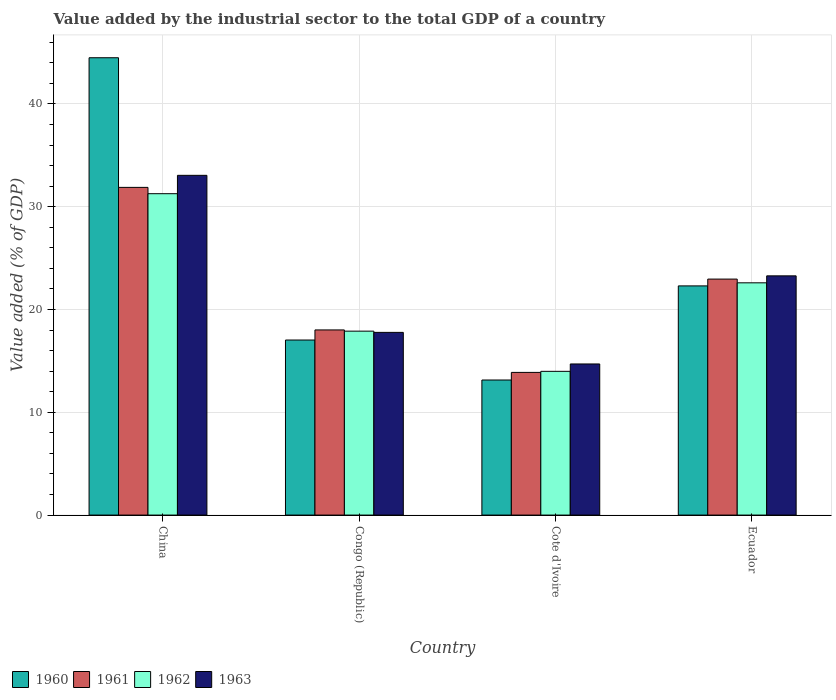How many groups of bars are there?
Offer a very short reply. 4. How many bars are there on the 4th tick from the left?
Your answer should be very brief. 4. What is the label of the 4th group of bars from the left?
Your answer should be compact. Ecuador. In how many cases, is the number of bars for a given country not equal to the number of legend labels?
Keep it short and to the point. 0. What is the value added by the industrial sector to the total GDP in 1963 in Congo (Republic)?
Your answer should be compact. 17.77. Across all countries, what is the maximum value added by the industrial sector to the total GDP in 1962?
Make the answer very short. 31.26. Across all countries, what is the minimum value added by the industrial sector to the total GDP in 1961?
Your answer should be compact. 13.88. In which country was the value added by the industrial sector to the total GDP in 1963 maximum?
Your answer should be compact. China. In which country was the value added by the industrial sector to the total GDP in 1961 minimum?
Offer a very short reply. Cote d'Ivoire. What is the total value added by the industrial sector to the total GDP in 1960 in the graph?
Ensure brevity in your answer.  96.95. What is the difference between the value added by the industrial sector to the total GDP in 1960 in China and that in Ecuador?
Ensure brevity in your answer.  22.19. What is the difference between the value added by the industrial sector to the total GDP in 1960 in Ecuador and the value added by the industrial sector to the total GDP in 1962 in Congo (Republic)?
Ensure brevity in your answer.  4.4. What is the average value added by the industrial sector to the total GDP in 1962 per country?
Your answer should be very brief. 21.43. What is the difference between the value added by the industrial sector to the total GDP of/in 1963 and value added by the industrial sector to the total GDP of/in 1961 in Cote d'Ivoire?
Your answer should be compact. 0.82. In how many countries, is the value added by the industrial sector to the total GDP in 1962 greater than 30 %?
Keep it short and to the point. 1. What is the ratio of the value added by the industrial sector to the total GDP in 1962 in China to that in Congo (Republic)?
Your answer should be compact. 1.75. Is the difference between the value added by the industrial sector to the total GDP in 1963 in Congo (Republic) and Cote d'Ivoire greater than the difference between the value added by the industrial sector to the total GDP in 1961 in Congo (Republic) and Cote d'Ivoire?
Give a very brief answer. No. What is the difference between the highest and the second highest value added by the industrial sector to the total GDP in 1963?
Your answer should be very brief. 15.28. What is the difference between the highest and the lowest value added by the industrial sector to the total GDP in 1963?
Keep it short and to the point. 18.35. Is it the case that in every country, the sum of the value added by the industrial sector to the total GDP in 1963 and value added by the industrial sector to the total GDP in 1962 is greater than the sum of value added by the industrial sector to the total GDP in 1960 and value added by the industrial sector to the total GDP in 1961?
Your response must be concise. No. What does the 1st bar from the left in Ecuador represents?
Give a very brief answer. 1960. What does the 3rd bar from the right in Congo (Republic) represents?
Offer a terse response. 1961. How many countries are there in the graph?
Provide a short and direct response. 4. Where does the legend appear in the graph?
Ensure brevity in your answer.  Bottom left. How many legend labels are there?
Provide a succinct answer. 4. How are the legend labels stacked?
Keep it short and to the point. Horizontal. What is the title of the graph?
Keep it short and to the point. Value added by the industrial sector to the total GDP of a country. Does "2011" appear as one of the legend labels in the graph?
Offer a terse response. No. What is the label or title of the X-axis?
Offer a very short reply. Country. What is the label or title of the Y-axis?
Keep it short and to the point. Value added (% of GDP). What is the Value added (% of GDP) in 1960 in China?
Your response must be concise. 44.49. What is the Value added (% of GDP) in 1961 in China?
Offer a very short reply. 31.88. What is the Value added (% of GDP) in 1962 in China?
Your answer should be compact. 31.26. What is the Value added (% of GDP) in 1963 in China?
Ensure brevity in your answer.  33.05. What is the Value added (% of GDP) of 1960 in Congo (Republic)?
Give a very brief answer. 17.03. What is the Value added (% of GDP) in 1961 in Congo (Republic)?
Provide a succinct answer. 18.01. What is the Value added (% of GDP) of 1962 in Congo (Republic)?
Offer a very short reply. 17.89. What is the Value added (% of GDP) in 1963 in Congo (Republic)?
Provide a succinct answer. 17.77. What is the Value added (% of GDP) in 1960 in Cote d'Ivoire?
Your response must be concise. 13.14. What is the Value added (% of GDP) of 1961 in Cote d'Ivoire?
Your response must be concise. 13.88. What is the Value added (% of GDP) in 1962 in Cote d'Ivoire?
Provide a short and direct response. 13.98. What is the Value added (% of GDP) of 1963 in Cote d'Ivoire?
Your answer should be compact. 14.7. What is the Value added (% of GDP) of 1960 in Ecuador?
Provide a succinct answer. 22.29. What is the Value added (% of GDP) of 1961 in Ecuador?
Offer a terse response. 22.96. What is the Value added (% of GDP) in 1962 in Ecuador?
Provide a short and direct response. 22.59. What is the Value added (% of GDP) in 1963 in Ecuador?
Offer a very short reply. 23.27. Across all countries, what is the maximum Value added (% of GDP) in 1960?
Ensure brevity in your answer.  44.49. Across all countries, what is the maximum Value added (% of GDP) of 1961?
Give a very brief answer. 31.88. Across all countries, what is the maximum Value added (% of GDP) of 1962?
Offer a very short reply. 31.26. Across all countries, what is the maximum Value added (% of GDP) of 1963?
Offer a terse response. 33.05. Across all countries, what is the minimum Value added (% of GDP) in 1960?
Your answer should be very brief. 13.14. Across all countries, what is the minimum Value added (% of GDP) in 1961?
Your response must be concise. 13.88. Across all countries, what is the minimum Value added (% of GDP) in 1962?
Provide a succinct answer. 13.98. Across all countries, what is the minimum Value added (% of GDP) in 1963?
Make the answer very short. 14.7. What is the total Value added (% of GDP) of 1960 in the graph?
Your response must be concise. 96.95. What is the total Value added (% of GDP) of 1961 in the graph?
Give a very brief answer. 86.72. What is the total Value added (% of GDP) of 1962 in the graph?
Your answer should be compact. 85.73. What is the total Value added (% of GDP) of 1963 in the graph?
Make the answer very short. 88.79. What is the difference between the Value added (% of GDP) in 1960 in China and that in Congo (Republic)?
Your response must be concise. 27.46. What is the difference between the Value added (% of GDP) of 1961 in China and that in Congo (Republic)?
Provide a short and direct response. 13.87. What is the difference between the Value added (% of GDP) in 1962 in China and that in Congo (Republic)?
Give a very brief answer. 13.37. What is the difference between the Value added (% of GDP) in 1963 in China and that in Congo (Republic)?
Offer a very short reply. 15.28. What is the difference between the Value added (% of GDP) in 1960 in China and that in Cote d'Ivoire?
Keep it short and to the point. 31.35. What is the difference between the Value added (% of GDP) in 1961 in China and that in Cote d'Ivoire?
Offer a very short reply. 18. What is the difference between the Value added (% of GDP) in 1962 in China and that in Cote d'Ivoire?
Ensure brevity in your answer.  17.28. What is the difference between the Value added (% of GDP) of 1963 in China and that in Cote d'Ivoire?
Keep it short and to the point. 18.35. What is the difference between the Value added (% of GDP) of 1960 in China and that in Ecuador?
Your answer should be compact. 22.19. What is the difference between the Value added (% of GDP) of 1961 in China and that in Ecuador?
Ensure brevity in your answer.  8.92. What is the difference between the Value added (% of GDP) of 1962 in China and that in Ecuador?
Make the answer very short. 8.67. What is the difference between the Value added (% of GDP) in 1963 in China and that in Ecuador?
Provide a succinct answer. 9.78. What is the difference between the Value added (% of GDP) in 1960 in Congo (Republic) and that in Cote d'Ivoire?
Offer a very short reply. 3.89. What is the difference between the Value added (% of GDP) of 1961 in Congo (Republic) and that in Cote d'Ivoire?
Offer a terse response. 4.13. What is the difference between the Value added (% of GDP) of 1962 in Congo (Republic) and that in Cote d'Ivoire?
Your response must be concise. 3.91. What is the difference between the Value added (% of GDP) in 1963 in Congo (Republic) and that in Cote d'Ivoire?
Offer a terse response. 3.07. What is the difference between the Value added (% of GDP) of 1960 in Congo (Republic) and that in Ecuador?
Ensure brevity in your answer.  -5.27. What is the difference between the Value added (% of GDP) of 1961 in Congo (Republic) and that in Ecuador?
Offer a terse response. -4.95. What is the difference between the Value added (% of GDP) in 1962 in Congo (Republic) and that in Ecuador?
Offer a very short reply. -4.7. What is the difference between the Value added (% of GDP) of 1963 in Congo (Republic) and that in Ecuador?
Your answer should be compact. -5.5. What is the difference between the Value added (% of GDP) in 1960 in Cote d'Ivoire and that in Ecuador?
Make the answer very short. -9.16. What is the difference between the Value added (% of GDP) of 1961 in Cote d'Ivoire and that in Ecuador?
Offer a terse response. -9.08. What is the difference between the Value added (% of GDP) in 1962 in Cote d'Ivoire and that in Ecuador?
Provide a short and direct response. -8.61. What is the difference between the Value added (% of GDP) of 1963 in Cote d'Ivoire and that in Ecuador?
Your answer should be very brief. -8.57. What is the difference between the Value added (% of GDP) of 1960 in China and the Value added (% of GDP) of 1961 in Congo (Republic)?
Your answer should be compact. 26.48. What is the difference between the Value added (% of GDP) in 1960 in China and the Value added (% of GDP) in 1962 in Congo (Republic)?
Keep it short and to the point. 26.6. What is the difference between the Value added (% of GDP) in 1960 in China and the Value added (% of GDP) in 1963 in Congo (Republic)?
Make the answer very short. 26.72. What is the difference between the Value added (% of GDP) in 1961 in China and the Value added (% of GDP) in 1962 in Congo (Republic)?
Offer a very short reply. 13.98. What is the difference between the Value added (% of GDP) in 1961 in China and the Value added (% of GDP) in 1963 in Congo (Republic)?
Provide a short and direct response. 14.1. What is the difference between the Value added (% of GDP) in 1962 in China and the Value added (% of GDP) in 1963 in Congo (Republic)?
Make the answer very short. 13.49. What is the difference between the Value added (% of GDP) in 1960 in China and the Value added (% of GDP) in 1961 in Cote d'Ivoire?
Provide a short and direct response. 30.61. What is the difference between the Value added (% of GDP) of 1960 in China and the Value added (% of GDP) of 1962 in Cote d'Ivoire?
Your answer should be very brief. 30.51. What is the difference between the Value added (% of GDP) in 1960 in China and the Value added (% of GDP) in 1963 in Cote d'Ivoire?
Your answer should be very brief. 29.79. What is the difference between the Value added (% of GDP) of 1961 in China and the Value added (% of GDP) of 1962 in Cote d'Ivoire?
Give a very brief answer. 17.9. What is the difference between the Value added (% of GDP) in 1961 in China and the Value added (% of GDP) in 1963 in Cote d'Ivoire?
Keep it short and to the point. 17.18. What is the difference between the Value added (% of GDP) in 1962 in China and the Value added (% of GDP) in 1963 in Cote d'Ivoire?
Offer a very short reply. 16.56. What is the difference between the Value added (% of GDP) in 1960 in China and the Value added (% of GDP) in 1961 in Ecuador?
Offer a very short reply. 21.53. What is the difference between the Value added (% of GDP) in 1960 in China and the Value added (% of GDP) in 1962 in Ecuador?
Ensure brevity in your answer.  21.9. What is the difference between the Value added (% of GDP) in 1960 in China and the Value added (% of GDP) in 1963 in Ecuador?
Give a very brief answer. 21.22. What is the difference between the Value added (% of GDP) in 1961 in China and the Value added (% of GDP) in 1962 in Ecuador?
Your answer should be very brief. 9.28. What is the difference between the Value added (% of GDP) in 1961 in China and the Value added (% of GDP) in 1963 in Ecuador?
Provide a succinct answer. 8.61. What is the difference between the Value added (% of GDP) of 1962 in China and the Value added (% of GDP) of 1963 in Ecuador?
Offer a terse response. 7.99. What is the difference between the Value added (% of GDP) in 1960 in Congo (Republic) and the Value added (% of GDP) in 1961 in Cote d'Ivoire?
Offer a very short reply. 3.15. What is the difference between the Value added (% of GDP) of 1960 in Congo (Republic) and the Value added (% of GDP) of 1962 in Cote d'Ivoire?
Your answer should be compact. 3.05. What is the difference between the Value added (% of GDP) in 1960 in Congo (Republic) and the Value added (% of GDP) in 1963 in Cote d'Ivoire?
Keep it short and to the point. 2.33. What is the difference between the Value added (% of GDP) in 1961 in Congo (Republic) and the Value added (% of GDP) in 1962 in Cote d'Ivoire?
Give a very brief answer. 4.03. What is the difference between the Value added (% of GDP) in 1961 in Congo (Republic) and the Value added (% of GDP) in 1963 in Cote d'Ivoire?
Offer a very short reply. 3.31. What is the difference between the Value added (% of GDP) in 1962 in Congo (Republic) and the Value added (% of GDP) in 1963 in Cote d'Ivoire?
Give a very brief answer. 3.19. What is the difference between the Value added (% of GDP) of 1960 in Congo (Republic) and the Value added (% of GDP) of 1961 in Ecuador?
Offer a very short reply. -5.93. What is the difference between the Value added (% of GDP) of 1960 in Congo (Republic) and the Value added (% of GDP) of 1962 in Ecuador?
Your answer should be compact. -5.57. What is the difference between the Value added (% of GDP) in 1960 in Congo (Republic) and the Value added (% of GDP) in 1963 in Ecuador?
Your answer should be very brief. -6.24. What is the difference between the Value added (% of GDP) in 1961 in Congo (Republic) and the Value added (% of GDP) in 1962 in Ecuador?
Offer a very short reply. -4.58. What is the difference between the Value added (% of GDP) of 1961 in Congo (Republic) and the Value added (% of GDP) of 1963 in Ecuador?
Your answer should be very brief. -5.26. What is the difference between the Value added (% of GDP) of 1962 in Congo (Republic) and the Value added (% of GDP) of 1963 in Ecuador?
Give a very brief answer. -5.38. What is the difference between the Value added (% of GDP) of 1960 in Cote d'Ivoire and the Value added (% of GDP) of 1961 in Ecuador?
Give a very brief answer. -9.82. What is the difference between the Value added (% of GDP) in 1960 in Cote d'Ivoire and the Value added (% of GDP) in 1962 in Ecuador?
Offer a terse response. -9.45. What is the difference between the Value added (% of GDP) in 1960 in Cote d'Ivoire and the Value added (% of GDP) in 1963 in Ecuador?
Your response must be concise. -10.13. What is the difference between the Value added (% of GDP) of 1961 in Cote d'Ivoire and the Value added (% of GDP) of 1962 in Ecuador?
Ensure brevity in your answer.  -8.71. What is the difference between the Value added (% of GDP) of 1961 in Cote d'Ivoire and the Value added (% of GDP) of 1963 in Ecuador?
Offer a very short reply. -9.39. What is the difference between the Value added (% of GDP) in 1962 in Cote d'Ivoire and the Value added (% of GDP) in 1963 in Ecuador?
Offer a terse response. -9.29. What is the average Value added (% of GDP) of 1960 per country?
Provide a succinct answer. 24.24. What is the average Value added (% of GDP) of 1961 per country?
Offer a terse response. 21.68. What is the average Value added (% of GDP) in 1962 per country?
Your answer should be compact. 21.43. What is the average Value added (% of GDP) of 1963 per country?
Provide a succinct answer. 22.2. What is the difference between the Value added (% of GDP) in 1960 and Value added (% of GDP) in 1961 in China?
Your answer should be very brief. 12.61. What is the difference between the Value added (% of GDP) in 1960 and Value added (% of GDP) in 1962 in China?
Make the answer very short. 13.23. What is the difference between the Value added (% of GDP) in 1960 and Value added (% of GDP) in 1963 in China?
Your answer should be very brief. 11.44. What is the difference between the Value added (% of GDP) of 1961 and Value added (% of GDP) of 1962 in China?
Your answer should be very brief. 0.61. What is the difference between the Value added (% of GDP) in 1961 and Value added (% of GDP) in 1963 in China?
Provide a short and direct response. -1.17. What is the difference between the Value added (% of GDP) in 1962 and Value added (% of GDP) in 1963 in China?
Give a very brief answer. -1.79. What is the difference between the Value added (% of GDP) of 1960 and Value added (% of GDP) of 1961 in Congo (Republic)?
Give a very brief answer. -0.98. What is the difference between the Value added (% of GDP) in 1960 and Value added (% of GDP) in 1962 in Congo (Republic)?
Provide a succinct answer. -0.86. What is the difference between the Value added (% of GDP) in 1960 and Value added (% of GDP) in 1963 in Congo (Republic)?
Make the answer very short. -0.74. What is the difference between the Value added (% of GDP) of 1961 and Value added (% of GDP) of 1962 in Congo (Republic)?
Your answer should be compact. 0.12. What is the difference between the Value added (% of GDP) of 1961 and Value added (% of GDP) of 1963 in Congo (Republic)?
Make the answer very short. 0.24. What is the difference between the Value added (% of GDP) of 1962 and Value added (% of GDP) of 1963 in Congo (Republic)?
Provide a succinct answer. 0.12. What is the difference between the Value added (% of GDP) in 1960 and Value added (% of GDP) in 1961 in Cote d'Ivoire?
Give a very brief answer. -0.74. What is the difference between the Value added (% of GDP) in 1960 and Value added (% of GDP) in 1962 in Cote d'Ivoire?
Provide a short and direct response. -0.84. What is the difference between the Value added (% of GDP) of 1960 and Value added (% of GDP) of 1963 in Cote d'Ivoire?
Provide a short and direct response. -1.56. What is the difference between the Value added (% of GDP) of 1961 and Value added (% of GDP) of 1962 in Cote d'Ivoire?
Your response must be concise. -0.1. What is the difference between the Value added (% of GDP) of 1961 and Value added (% of GDP) of 1963 in Cote d'Ivoire?
Your answer should be compact. -0.82. What is the difference between the Value added (% of GDP) of 1962 and Value added (% of GDP) of 1963 in Cote d'Ivoire?
Provide a short and direct response. -0.72. What is the difference between the Value added (% of GDP) of 1960 and Value added (% of GDP) of 1961 in Ecuador?
Give a very brief answer. -0.66. What is the difference between the Value added (% of GDP) of 1960 and Value added (% of GDP) of 1962 in Ecuador?
Give a very brief answer. -0.3. What is the difference between the Value added (% of GDP) in 1960 and Value added (% of GDP) in 1963 in Ecuador?
Ensure brevity in your answer.  -0.98. What is the difference between the Value added (% of GDP) of 1961 and Value added (% of GDP) of 1962 in Ecuador?
Offer a very short reply. 0.36. What is the difference between the Value added (% of GDP) in 1961 and Value added (% of GDP) in 1963 in Ecuador?
Keep it short and to the point. -0.31. What is the difference between the Value added (% of GDP) of 1962 and Value added (% of GDP) of 1963 in Ecuador?
Your response must be concise. -0.68. What is the ratio of the Value added (% of GDP) in 1960 in China to that in Congo (Republic)?
Make the answer very short. 2.61. What is the ratio of the Value added (% of GDP) of 1961 in China to that in Congo (Republic)?
Offer a terse response. 1.77. What is the ratio of the Value added (% of GDP) in 1962 in China to that in Congo (Republic)?
Your answer should be compact. 1.75. What is the ratio of the Value added (% of GDP) in 1963 in China to that in Congo (Republic)?
Make the answer very short. 1.86. What is the ratio of the Value added (% of GDP) in 1960 in China to that in Cote d'Ivoire?
Provide a short and direct response. 3.39. What is the ratio of the Value added (% of GDP) in 1961 in China to that in Cote d'Ivoire?
Offer a terse response. 2.3. What is the ratio of the Value added (% of GDP) of 1962 in China to that in Cote d'Ivoire?
Ensure brevity in your answer.  2.24. What is the ratio of the Value added (% of GDP) of 1963 in China to that in Cote d'Ivoire?
Your response must be concise. 2.25. What is the ratio of the Value added (% of GDP) in 1960 in China to that in Ecuador?
Your answer should be very brief. 2. What is the ratio of the Value added (% of GDP) of 1961 in China to that in Ecuador?
Your answer should be very brief. 1.39. What is the ratio of the Value added (% of GDP) in 1962 in China to that in Ecuador?
Your answer should be very brief. 1.38. What is the ratio of the Value added (% of GDP) in 1963 in China to that in Ecuador?
Give a very brief answer. 1.42. What is the ratio of the Value added (% of GDP) of 1960 in Congo (Republic) to that in Cote d'Ivoire?
Your response must be concise. 1.3. What is the ratio of the Value added (% of GDP) of 1961 in Congo (Republic) to that in Cote d'Ivoire?
Keep it short and to the point. 1.3. What is the ratio of the Value added (% of GDP) in 1962 in Congo (Republic) to that in Cote d'Ivoire?
Keep it short and to the point. 1.28. What is the ratio of the Value added (% of GDP) of 1963 in Congo (Republic) to that in Cote d'Ivoire?
Offer a terse response. 1.21. What is the ratio of the Value added (% of GDP) in 1960 in Congo (Republic) to that in Ecuador?
Keep it short and to the point. 0.76. What is the ratio of the Value added (% of GDP) of 1961 in Congo (Republic) to that in Ecuador?
Give a very brief answer. 0.78. What is the ratio of the Value added (% of GDP) of 1962 in Congo (Republic) to that in Ecuador?
Your response must be concise. 0.79. What is the ratio of the Value added (% of GDP) in 1963 in Congo (Republic) to that in Ecuador?
Offer a very short reply. 0.76. What is the ratio of the Value added (% of GDP) in 1960 in Cote d'Ivoire to that in Ecuador?
Ensure brevity in your answer.  0.59. What is the ratio of the Value added (% of GDP) in 1961 in Cote d'Ivoire to that in Ecuador?
Give a very brief answer. 0.6. What is the ratio of the Value added (% of GDP) in 1962 in Cote d'Ivoire to that in Ecuador?
Your answer should be compact. 0.62. What is the ratio of the Value added (% of GDP) in 1963 in Cote d'Ivoire to that in Ecuador?
Your answer should be very brief. 0.63. What is the difference between the highest and the second highest Value added (% of GDP) in 1960?
Your answer should be very brief. 22.19. What is the difference between the highest and the second highest Value added (% of GDP) in 1961?
Provide a succinct answer. 8.92. What is the difference between the highest and the second highest Value added (% of GDP) in 1962?
Offer a very short reply. 8.67. What is the difference between the highest and the second highest Value added (% of GDP) in 1963?
Offer a terse response. 9.78. What is the difference between the highest and the lowest Value added (% of GDP) in 1960?
Provide a succinct answer. 31.35. What is the difference between the highest and the lowest Value added (% of GDP) of 1961?
Provide a succinct answer. 18. What is the difference between the highest and the lowest Value added (% of GDP) in 1962?
Provide a short and direct response. 17.28. What is the difference between the highest and the lowest Value added (% of GDP) of 1963?
Provide a succinct answer. 18.35. 